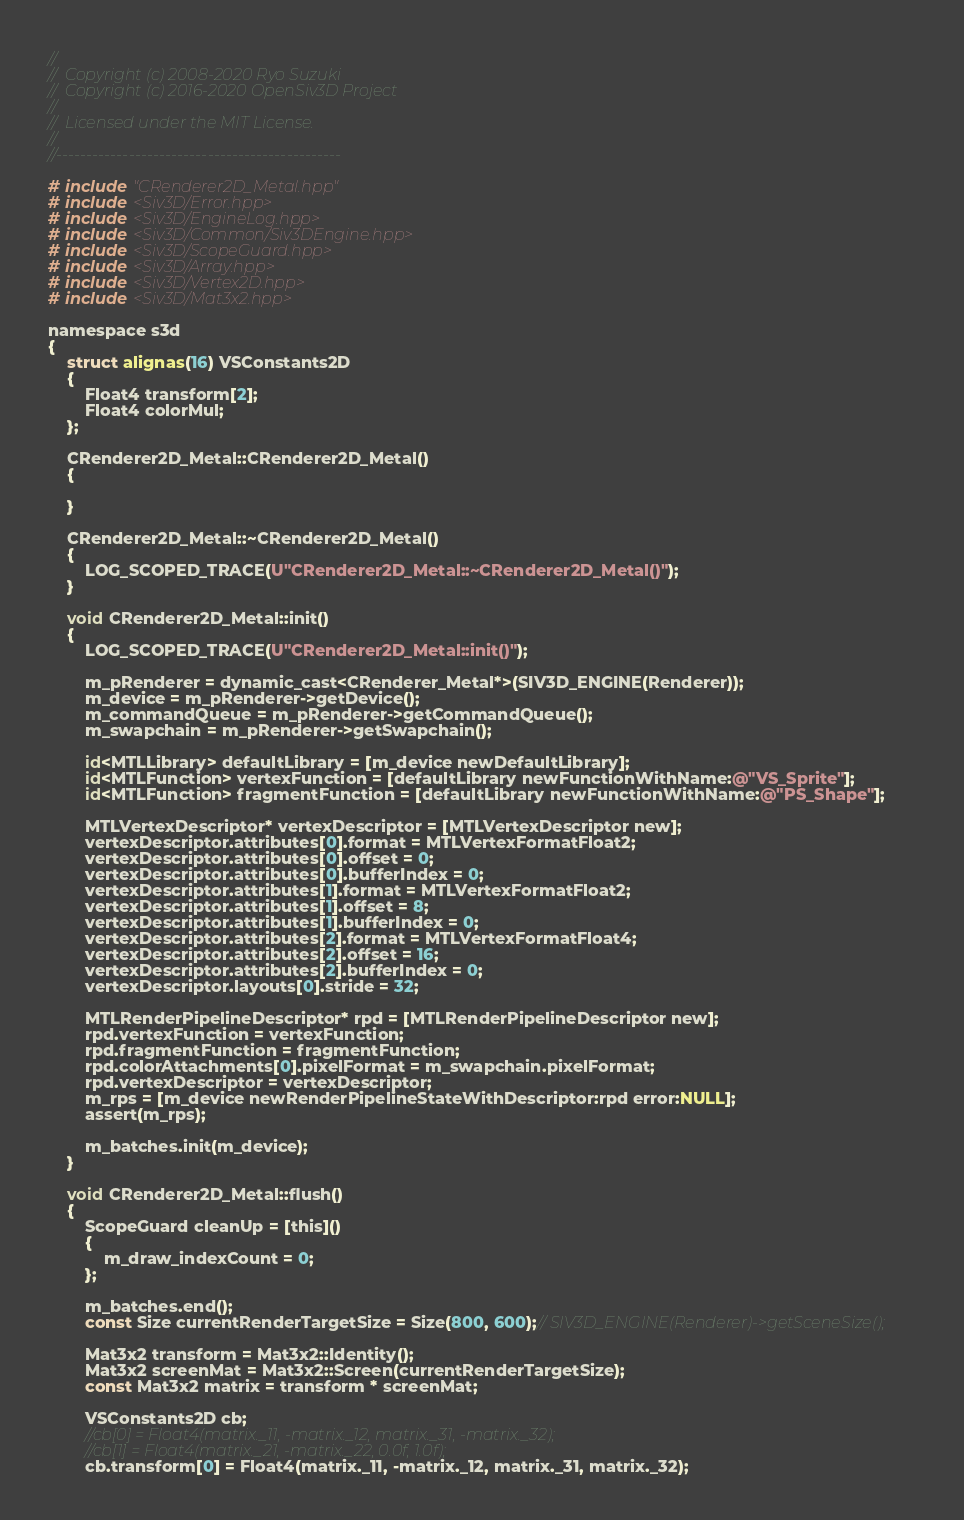Convert code to text. <code><loc_0><loc_0><loc_500><loc_500><_ObjectiveC_>//
//	Copyright (c) 2008-2020 Ryo Suzuki
//	Copyright (c) 2016-2020 OpenSiv3D Project
//
//	Licensed under the MIT License.
//
//-----------------------------------------------

# include "CRenderer2D_Metal.hpp"
# include <Siv3D/Error.hpp>
# include <Siv3D/EngineLog.hpp>
# include <Siv3D/Common/Siv3DEngine.hpp>
# include <Siv3D/ScopeGuard.hpp>
# include <Siv3D/Array.hpp>
# include <Siv3D/Vertex2D.hpp>
# include <Siv3D/Mat3x2.hpp>

namespace s3d
{
	struct alignas(16) VSConstants2D
	{
		Float4 transform[2];
		Float4 colorMul;
	};

	CRenderer2D_Metal::CRenderer2D_Metal()
	{
	
	}

	CRenderer2D_Metal::~CRenderer2D_Metal()
	{
		LOG_SCOPED_TRACE(U"CRenderer2D_Metal::~CRenderer2D_Metal()");
	}

	void CRenderer2D_Metal::init()
	{
		LOG_SCOPED_TRACE(U"CRenderer2D_Metal::init()");
		
		m_pRenderer = dynamic_cast<CRenderer_Metal*>(SIV3D_ENGINE(Renderer));
		m_device = m_pRenderer->getDevice();
		m_commandQueue = m_pRenderer->getCommandQueue();
		m_swapchain = m_pRenderer->getSwapchain();
	
		id<MTLLibrary> defaultLibrary = [m_device newDefaultLibrary];
		id<MTLFunction> vertexFunction = [defaultLibrary newFunctionWithName:@"VS_Sprite"];
		id<MTLFunction> fragmentFunction = [defaultLibrary newFunctionWithName:@"PS_Shape"];
		
		MTLVertexDescriptor* vertexDescriptor = [MTLVertexDescriptor new];
		vertexDescriptor.attributes[0].format = MTLVertexFormatFloat2;
		vertexDescriptor.attributes[0].offset = 0;
		vertexDescriptor.attributes[0].bufferIndex = 0;
		vertexDescriptor.attributes[1].format = MTLVertexFormatFloat2;
		vertexDescriptor.attributes[1].offset = 8;
		vertexDescriptor.attributes[1].bufferIndex = 0;
		vertexDescriptor.attributes[2].format = MTLVertexFormatFloat4;
		vertexDescriptor.attributes[2].offset = 16;
		vertexDescriptor.attributes[2].bufferIndex = 0;
		vertexDescriptor.layouts[0].stride = 32;
		 
		MTLRenderPipelineDescriptor* rpd = [MTLRenderPipelineDescriptor new];
		rpd.vertexFunction = vertexFunction;
		rpd.fragmentFunction = fragmentFunction;
		rpd.colorAttachments[0].pixelFormat = m_swapchain.pixelFormat;
		rpd.vertexDescriptor = vertexDescriptor;
		m_rps = [m_device newRenderPipelineStateWithDescriptor:rpd error:NULL];
		assert(m_rps);
		
		m_batches.init(m_device);
	}

	void CRenderer2D_Metal::flush()
	{
		ScopeGuard cleanUp = [this]()
		{
			m_draw_indexCount = 0;
		};
		
		m_batches.end();
		const Size currentRenderTargetSize = Size(800, 600);// SIV3D_ENGINE(Renderer)->getSceneSize();

		Mat3x2 transform = Mat3x2::Identity();
		Mat3x2 screenMat = Mat3x2::Screen(currentRenderTargetSize);
		const Mat3x2 matrix = transform * screenMat;
		
		VSConstants2D cb;
		//cb[0] = Float4(matrix._11, -matrix._12, matrix._31, -matrix._32);
		//cb[1] = Float4(matrix._21, -matrix._22, 0.0f, 1.0f);
		cb.transform[0] = Float4(matrix._11, -matrix._12, matrix._31, matrix._32);</code> 